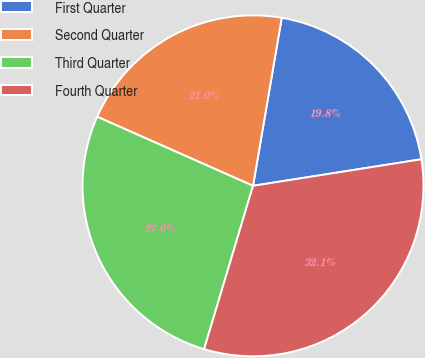Convert chart to OTSL. <chart><loc_0><loc_0><loc_500><loc_500><pie_chart><fcel>First Quarter<fcel>Second Quarter<fcel>Third Quarter<fcel>Fourth Quarter<nl><fcel>19.82%<fcel>21.05%<fcel>27.01%<fcel>32.12%<nl></chart> 